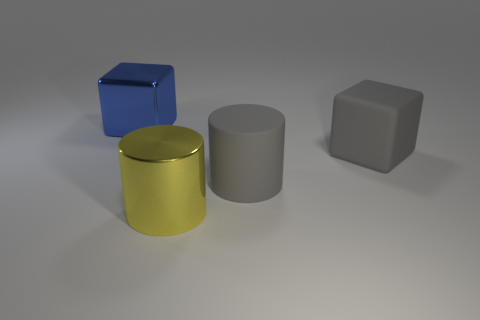There is a big metal object right of the blue shiny thing; does it have the same color as the rubber block?
Offer a very short reply. No. What number of other things are the same size as the metallic cube?
Your response must be concise. 3. Do the large yellow cylinder and the big gray cylinder have the same material?
Make the answer very short. No. There is a metallic object that is behind the large yellow shiny cylinder that is in front of the big rubber cube; what is its color?
Your response must be concise. Blue. What is the size of the gray matte object that is the same shape as the large yellow thing?
Provide a succinct answer. Large. Does the matte cylinder have the same color as the large metal cube?
Make the answer very short. No. What number of shiny cylinders are behind the shiny object that is in front of the large object left of the metal cylinder?
Your answer should be compact. 0. Is the number of purple shiny things greater than the number of large yellow metallic objects?
Your response must be concise. No. How many objects are there?
Make the answer very short. 4. The gray rubber thing that is in front of the big gray object behind the gray matte object that is to the left of the gray rubber block is what shape?
Your response must be concise. Cylinder. 